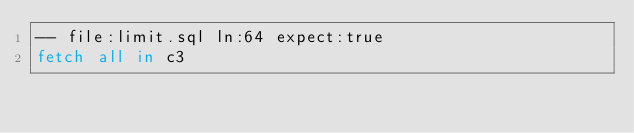<code> <loc_0><loc_0><loc_500><loc_500><_SQL_>-- file:limit.sql ln:64 expect:true
fetch all in c3
</code> 